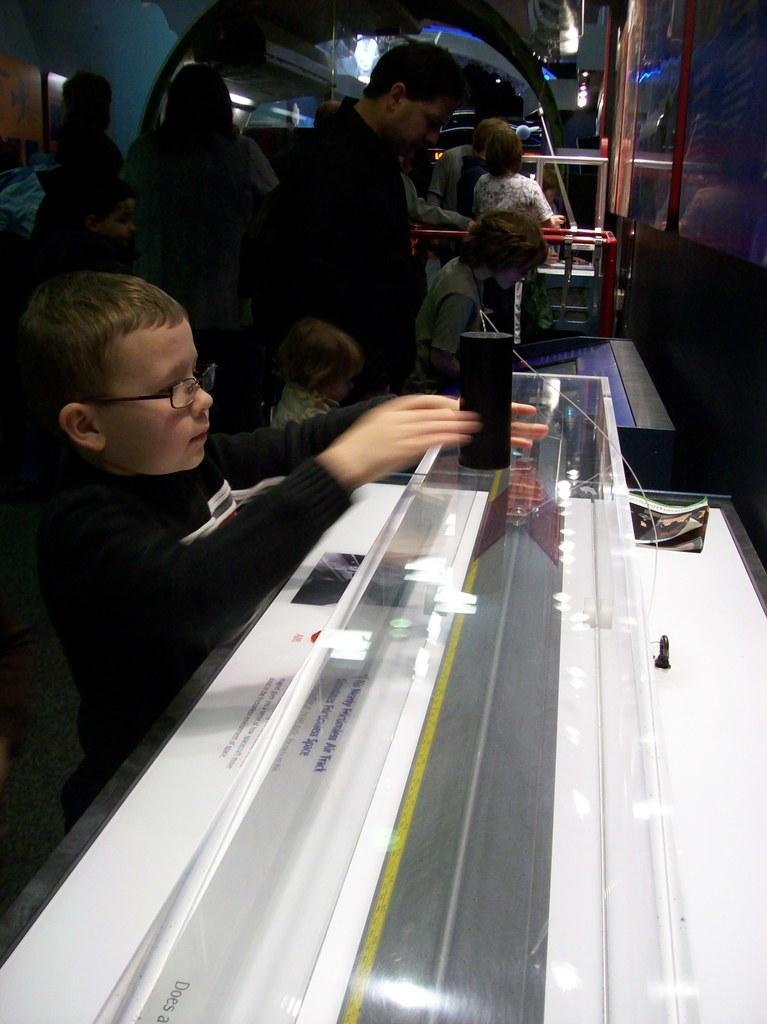In one or two sentences, can you explain what this image depicts? In this picture we can see a device and some text is visible on a white surface. There are a few kids and some people at the back. We can see a few objects in the background. 